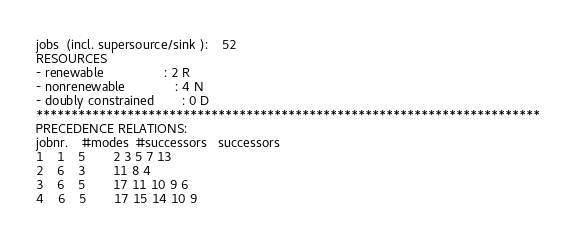<code> <loc_0><loc_0><loc_500><loc_500><_ObjectiveC_>jobs  (incl. supersource/sink ):	52
RESOURCES
- renewable                 : 2 R
- nonrenewable              : 4 N
- doubly constrained        : 0 D
************************************************************************
PRECEDENCE RELATIONS:
jobnr.    #modes  #successors   successors
1	1	5		2 3 5 7 13 
2	6	3		11 8 4 
3	6	5		17 11 10 9 6 
4	6	5		17 15 14 10 9 </code> 